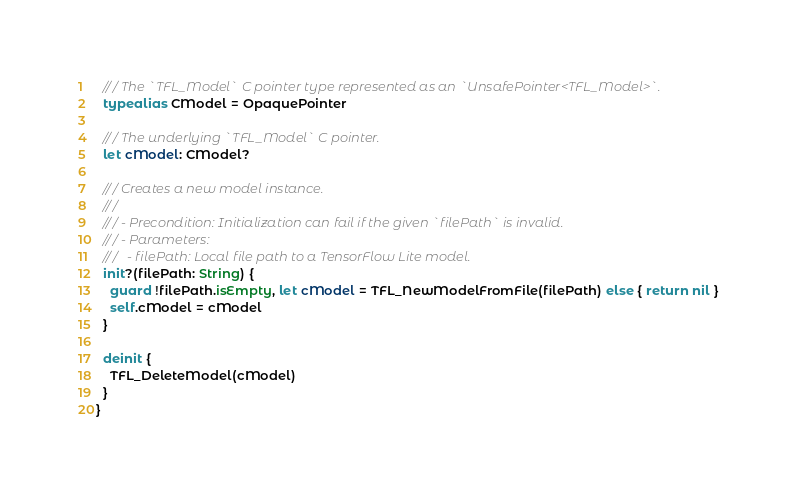Convert code to text. <code><loc_0><loc_0><loc_500><loc_500><_Swift_>  /// The `TFL_Model` C pointer type represented as an `UnsafePointer<TFL_Model>`.
  typealias CModel = OpaquePointer

  /// The underlying `TFL_Model` C pointer.
  let cModel: CModel?

  /// Creates a new model instance.
  ///
  /// - Precondition: Initialization can fail if the given `filePath` is invalid.
  /// - Parameters:
  ///   - filePath: Local file path to a TensorFlow Lite model.
  init?(filePath: String) {
    guard !filePath.isEmpty, let cModel = TFL_NewModelFromFile(filePath) else { return nil }
    self.cModel = cModel
  }

  deinit {
    TFL_DeleteModel(cModel)
  }
}
</code> 